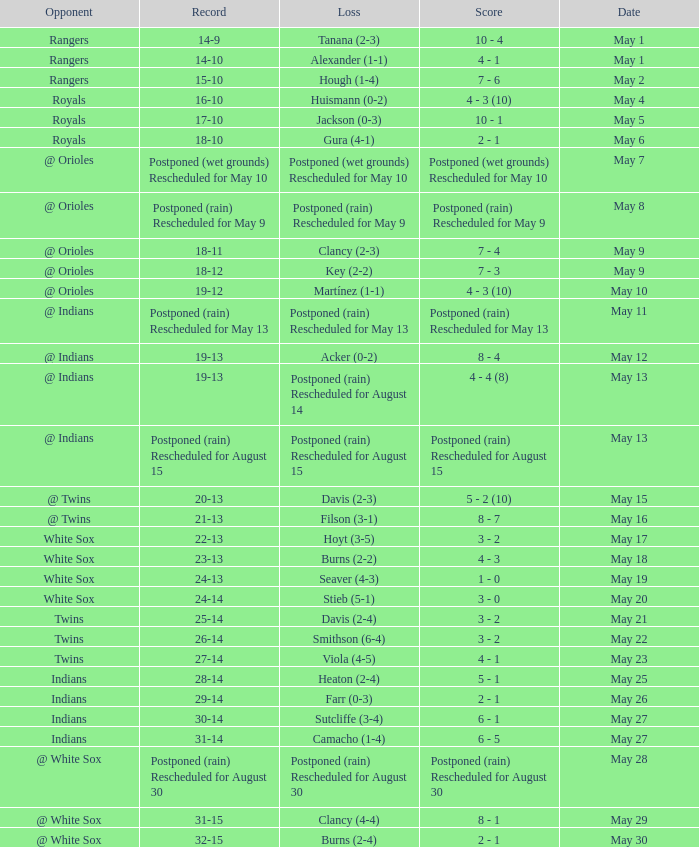What was the loss of the game when the record was 21-13? Filson (3-1). 